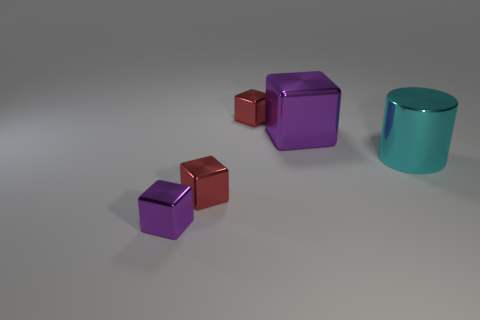Add 1 big cylinders. How many objects exist? 6 Subtract all cubes. How many objects are left? 1 Subtract all metal things. Subtract all large blue shiny balls. How many objects are left? 0 Add 3 large blocks. How many large blocks are left? 4 Add 1 tiny shiny spheres. How many tiny shiny spheres exist? 1 Subtract 0 brown blocks. How many objects are left? 5 